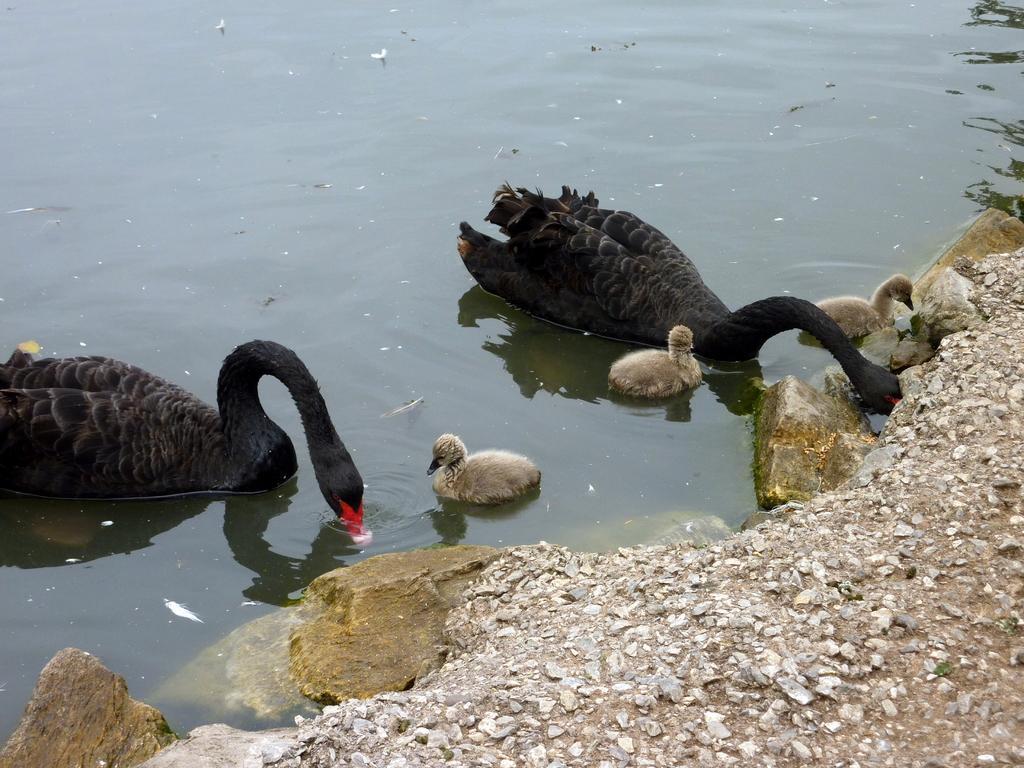Could you give a brief overview of what you see in this image? In this image I can see birds swimming in the water. On the right side I can see some land surface. 